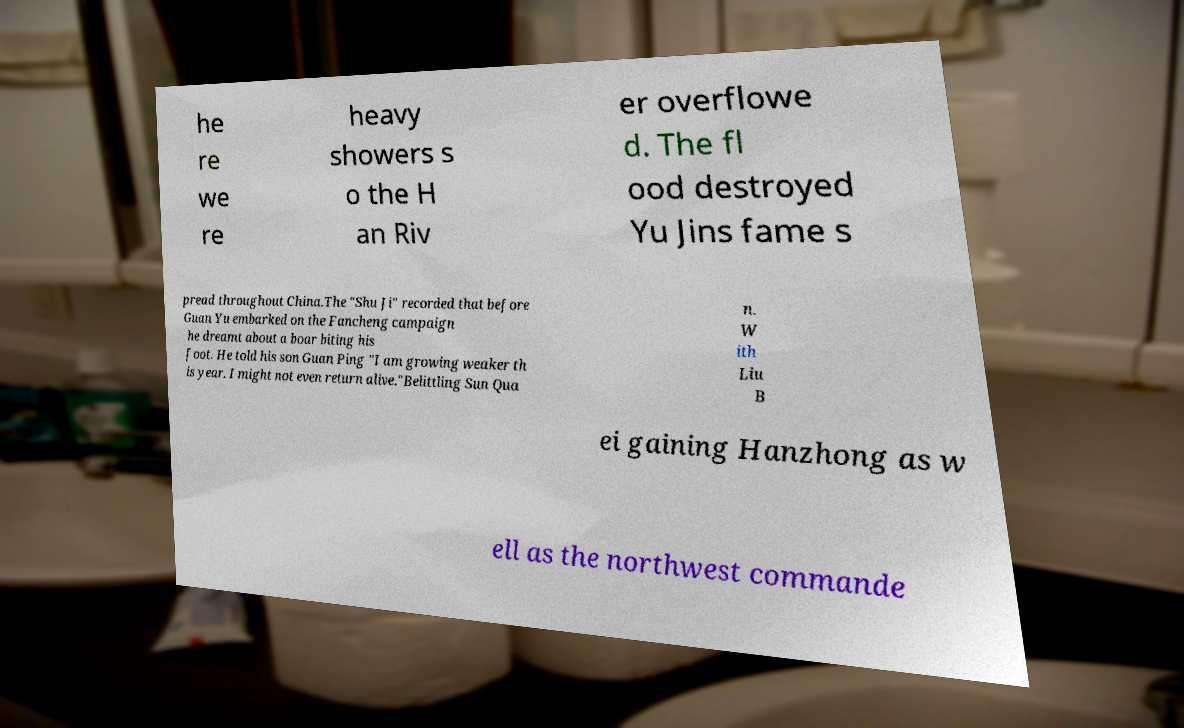Can you accurately transcribe the text from the provided image for me? he re we re heavy showers s o the H an Riv er overflowe d. The fl ood destroyed Yu Jins fame s pread throughout China.The "Shu Ji" recorded that before Guan Yu embarked on the Fancheng campaign he dreamt about a boar biting his foot. He told his son Guan Ping "I am growing weaker th is year. I might not even return alive."Belittling Sun Qua n. W ith Liu B ei gaining Hanzhong as w ell as the northwest commande 